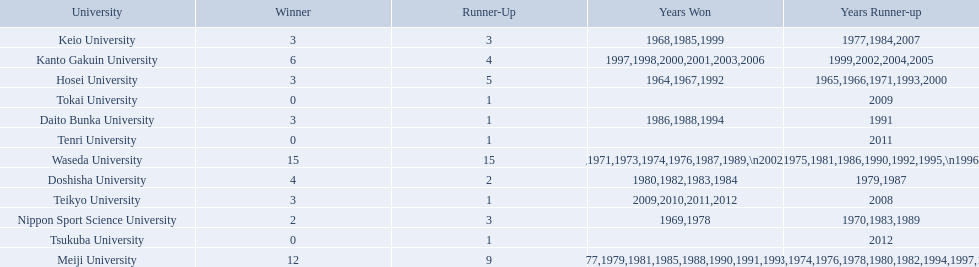What are all of the universities? Waseda University, Meiji University, Kanto Gakuin University, Doshisha University, Hosei University, Keio University, Daito Bunka University, Nippon Sport Science University, Teikyo University, Tokai University, Tenri University, Tsukuba University. And their scores? 15, 12, 6, 4, 3, 3, 3, 2, 3, 0, 0, 0. Which university scored won the most? Waseda University. Can you parse all the data within this table? {'header': ['University', 'Winner', 'Runner-Up', 'Years Won', 'Years Runner-up'], 'rows': [['Keio University', '3', '3', '1968,1985,1999', '1977,1984,2007'], ['Kanto Gakuin University', '6', '4', '1997,1998,2000,2001,2003,2006', '1999,2002,2004,2005'], ['Hosei University', '3', '5', '1964,1967,1992', '1965,1966,1971,1993,2000'], ['Tokai University', '0', '1', '', '2009'], ['Daito Bunka University', '3', '1', '1986,1988,1994', '1991'], ['Tenri University', '0', '1', '', '2011'], ['Waseda University', '15', '15', '1965,1966,1968,1970,1971,1973,1974,1976,1987,1989,\\n2002,2004,2005,2007,2008', '1964,1967,1969,1972,1975,1981,1986,1990,1992,1995,\\n1996,2001,2003,2006,2010'], ['Doshisha University', '4', '2', '1980,1982,1983,1984', '1979,1987'], ['Teikyo University', '3', '1', '2009,2010,2011,2012', '2008'], ['Nippon Sport Science University', '2', '3', '1969,1978', '1970,1983,1989'], ['Tsukuba University', '0', '1', '', '2012'], ['Meiji University', '12', '9', '1972,1975,1977,1979,1981,1985,1988,1990,1991,1993,\\n1995,1996', '1973,1974,1976,1978,1980,1982,1994,1997,1998']]} 